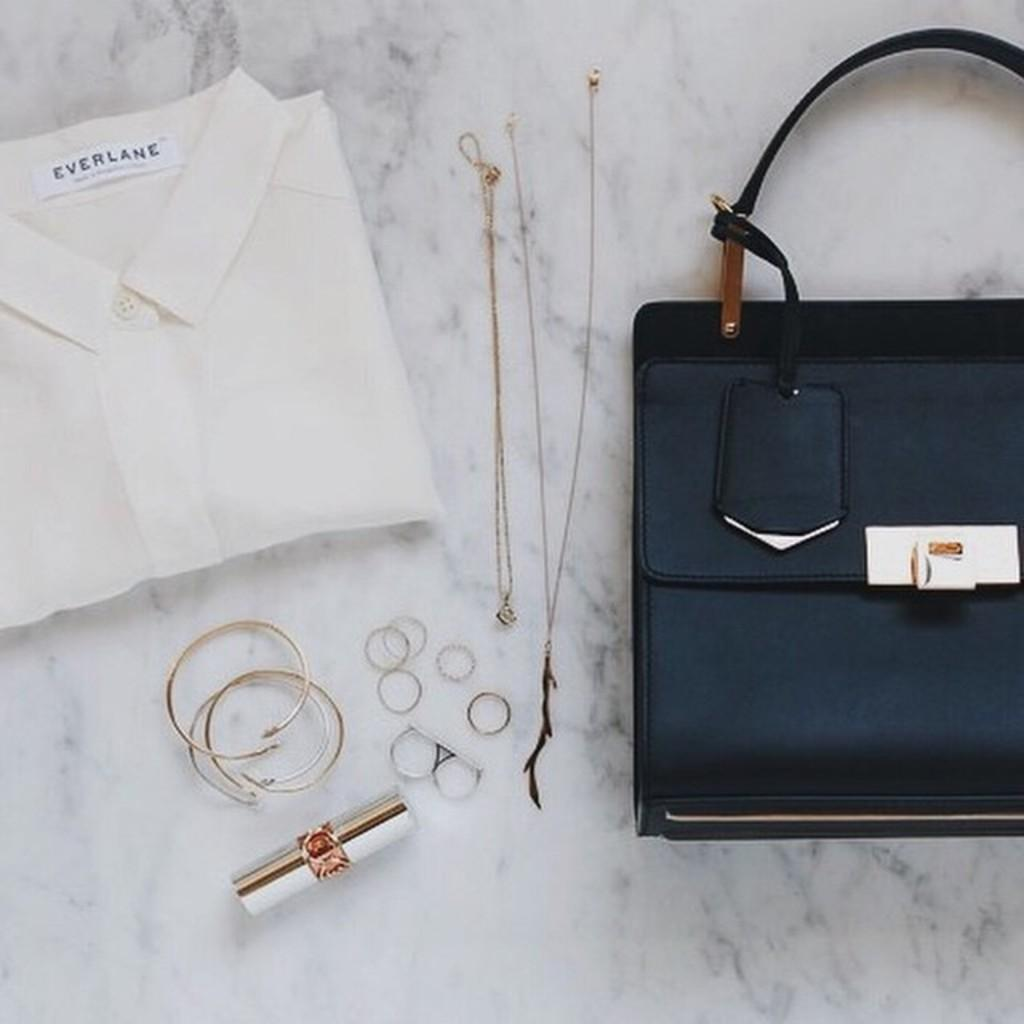What object can be seen in the image that might be used for carrying items? There is a bag in the image that can be used for carrying items. What else is visible in the image that might be used for personal adornment? There are accessories in the image that can be used for personal adornment. What type of clothing is present in the image? There is a shirt in the image. What type of pen can be seen in the image? There is no pen present in the image. What kind of flower is depicted on the shirt in the image? There is no flower depicted on the shirt in the image. 